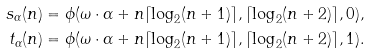Convert formula to latex. <formula><loc_0><loc_0><loc_500><loc_500>s _ { \alpha } ( n ) & = \phi ( \omega \cdot \alpha + n \lceil \log _ { 2 } ( n + 1 ) \rceil , \lceil \log _ { 2 } ( n + 2 ) \rceil , 0 ) , \\ t _ { \alpha } ( n ) & = \phi ( \omega \cdot \alpha + n \lceil \log _ { 2 } ( n + 1 ) \rceil , \lceil \log _ { 2 } ( n + 2 ) \rceil , 1 ) .</formula> 